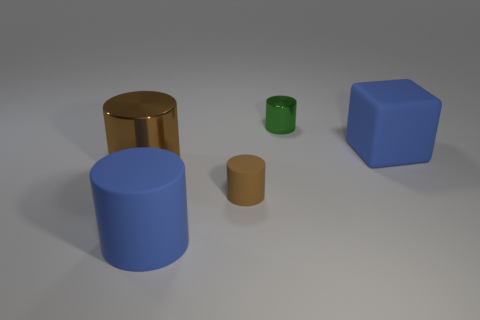Subtract all green cylinders. How many cylinders are left? 3 Subtract all gray cylinders. Subtract all blue cubes. How many cylinders are left? 4 Add 1 brown metallic cylinders. How many objects exist? 6 Subtract all cylinders. How many objects are left? 1 Add 5 blue blocks. How many blue blocks are left? 6 Add 2 green rubber cubes. How many green rubber cubes exist? 2 Subtract 0 yellow cylinders. How many objects are left? 5 Subtract all big blue cylinders. Subtract all large brown cylinders. How many objects are left? 3 